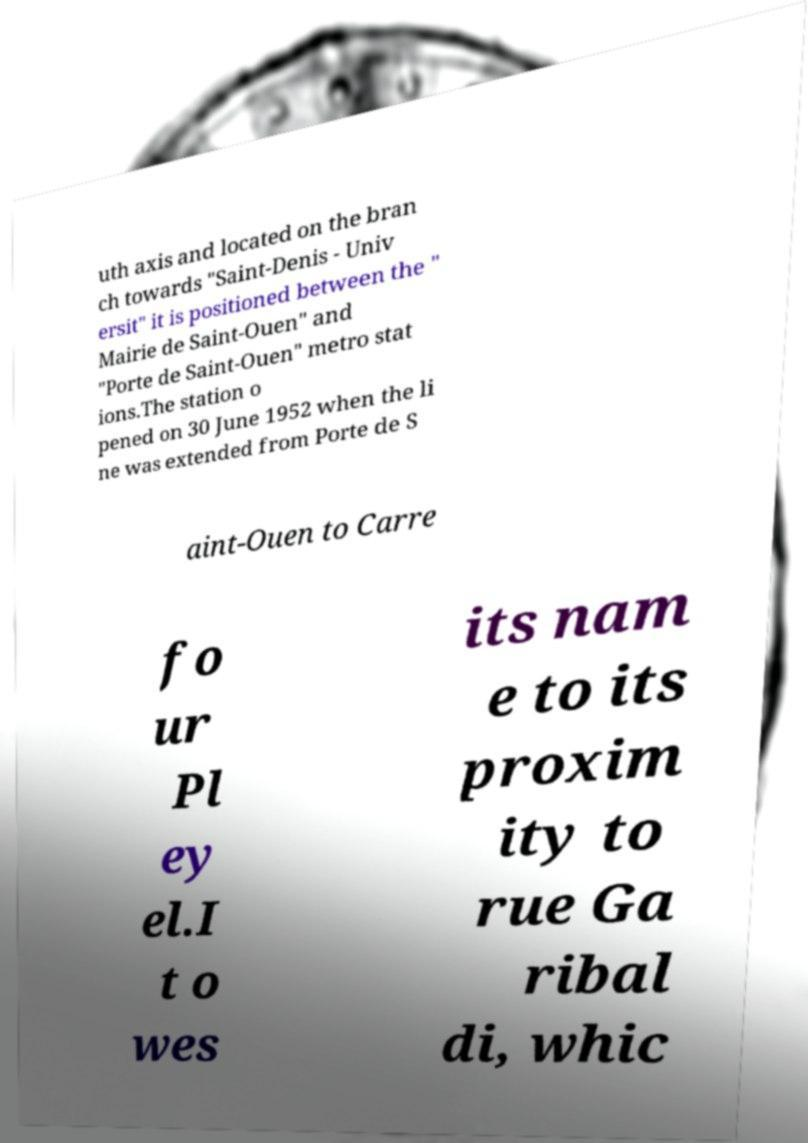Can you read and provide the text displayed in the image?This photo seems to have some interesting text. Can you extract and type it out for me? uth axis and located on the bran ch towards "Saint-Denis - Univ ersit" it is positioned between the " Mairie de Saint-Ouen" and "Porte de Saint-Ouen" metro stat ions.The station o pened on 30 June 1952 when the li ne was extended from Porte de S aint-Ouen to Carre fo ur Pl ey el.I t o wes its nam e to its proxim ity to rue Ga ribal di, whic 